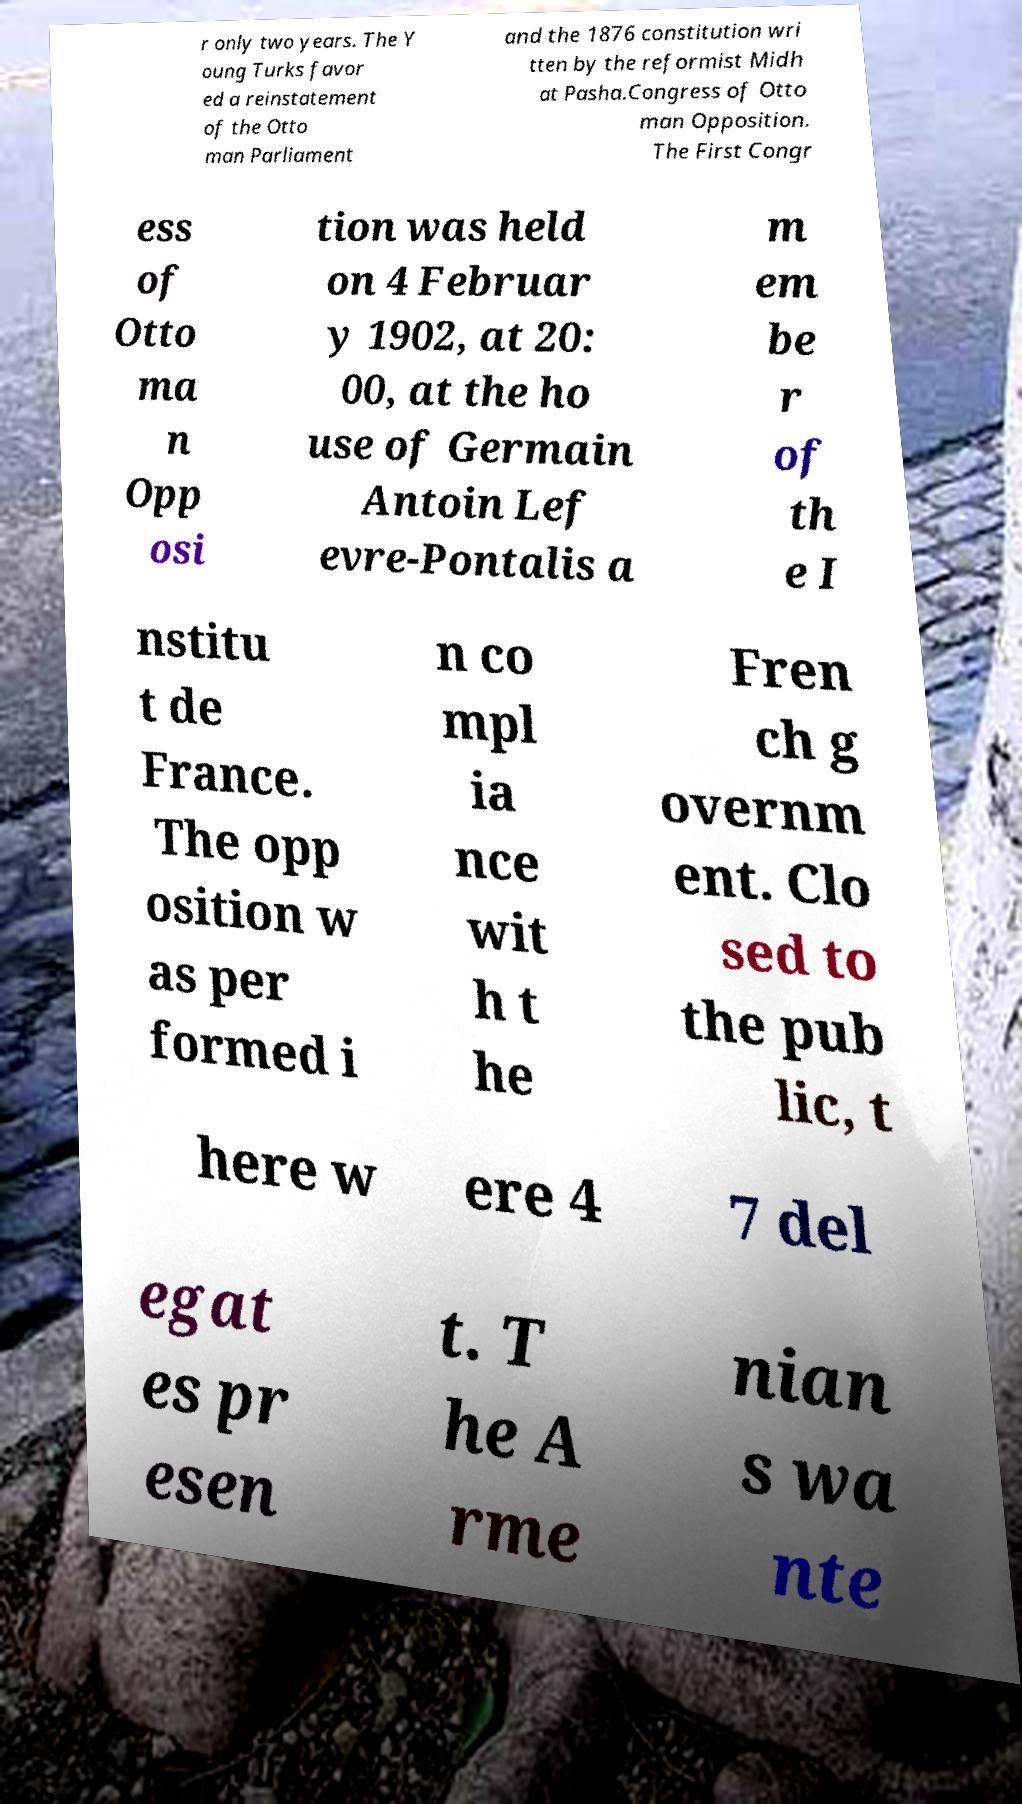Please read and relay the text visible in this image. What does it say? r only two years. The Y oung Turks favor ed a reinstatement of the Otto man Parliament and the 1876 constitution wri tten by the reformist Midh at Pasha.Congress of Otto man Opposition. The First Congr ess of Otto ma n Opp osi tion was held on 4 Februar y 1902, at 20: 00, at the ho use of Germain Antoin Lef evre-Pontalis a m em be r of th e I nstitu t de France. The opp osition w as per formed i n co mpl ia nce wit h t he Fren ch g overnm ent. Clo sed to the pub lic, t here w ere 4 7 del egat es pr esen t. T he A rme nian s wa nte 